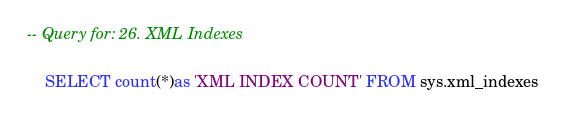<code> <loc_0><loc_0><loc_500><loc_500><_SQL_>-- Query for: 26. XML Indexes

    SELECT count(*)as 'XML INDEX COUNT' FROM sys.xml_indexes
    

</code> 